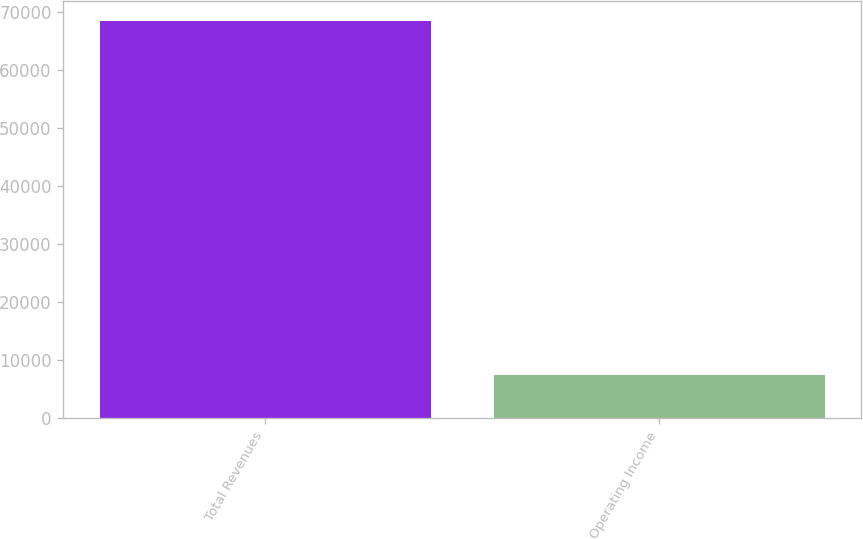Convert chart. <chart><loc_0><loc_0><loc_500><loc_500><bar_chart><fcel>Total Revenues<fcel>Operating Income<nl><fcel>68483<fcel>7500<nl></chart> 